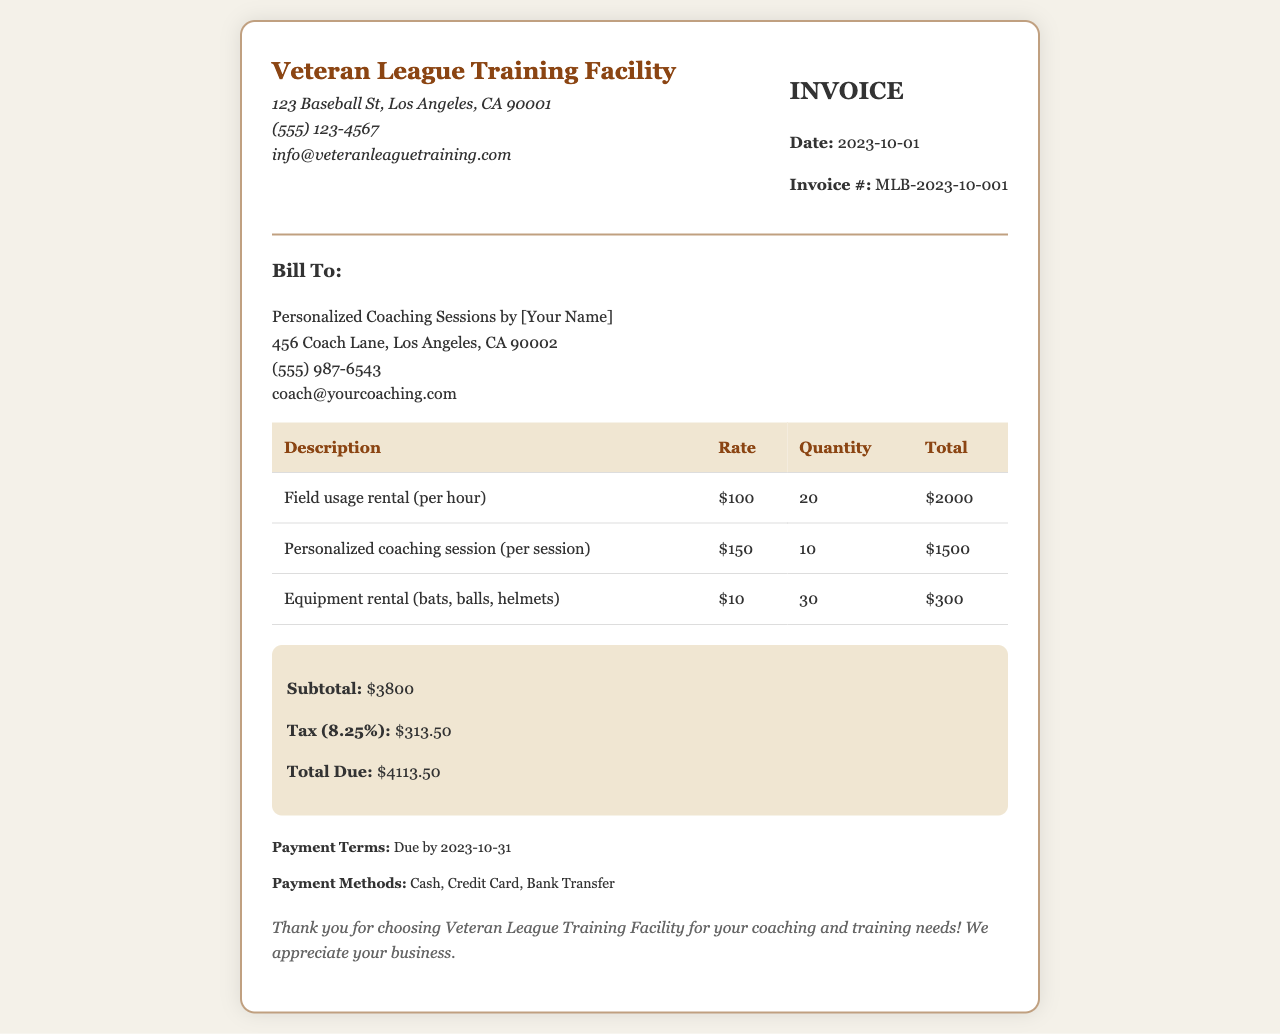What is the invoice number? The invoice number is specified near the top of the document.
Answer: MLB-2023-10-001 What is the subtotal amount? The subtotal amount is found in the summary section of the invoice.
Answer: $3800 How many personalized coaching sessions were included? The number of personalized coaching sessions can be found in the table under the quantity column.
Answer: 10 What is the tax rate applied? The tax rate is specified in the summary section of the document.
Answer: 8.25% What is the total due amount? The total due amount is calculated and presented in the summary section.
Answer: $4113.50 When is the payment due? The payment due date is listed in the payment terms section of the invoice.
Answer: 2023-10-31 What is the rate for field usage rental? The rate for field usage rental is mentioned in the table under the rate column.
Answer: $100 What methods of payment are accepted? The payment methods accepted are listed in the payment terms section.
Answer: Cash, Credit Card, Bank Transfer What address is listed for the Veteran League Training Facility? The address for the facility is located in the header section of the invoice.
Answer: 123 Baseball St, Los Angeles, CA 90001 